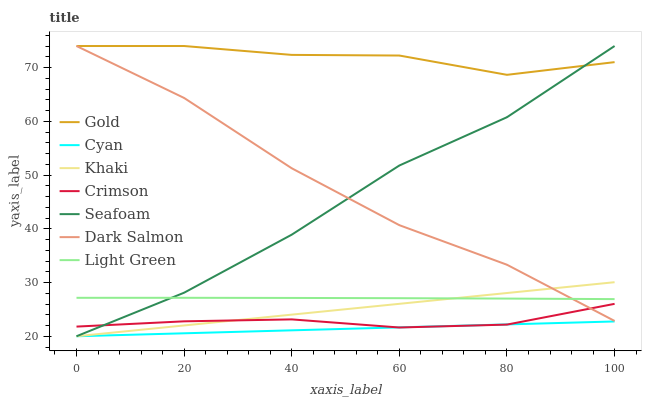Does Cyan have the minimum area under the curve?
Answer yes or no. Yes. Does Gold have the maximum area under the curve?
Answer yes or no. Yes. Does Seafoam have the minimum area under the curve?
Answer yes or no. No. Does Seafoam have the maximum area under the curve?
Answer yes or no. No. Is Khaki the smoothest?
Answer yes or no. Yes. Is Seafoam the roughest?
Answer yes or no. Yes. Is Gold the smoothest?
Answer yes or no. No. Is Gold the roughest?
Answer yes or no. No. Does Gold have the lowest value?
Answer yes or no. No. Does Dark Salmon have the highest value?
Answer yes or no. Yes. Does Light Green have the highest value?
Answer yes or no. No. Is Khaki less than Gold?
Answer yes or no. Yes. Is Gold greater than Crimson?
Answer yes or no. Yes. Does Seafoam intersect Gold?
Answer yes or no. Yes. Is Seafoam less than Gold?
Answer yes or no. No. Is Seafoam greater than Gold?
Answer yes or no. No. Does Khaki intersect Gold?
Answer yes or no. No. 